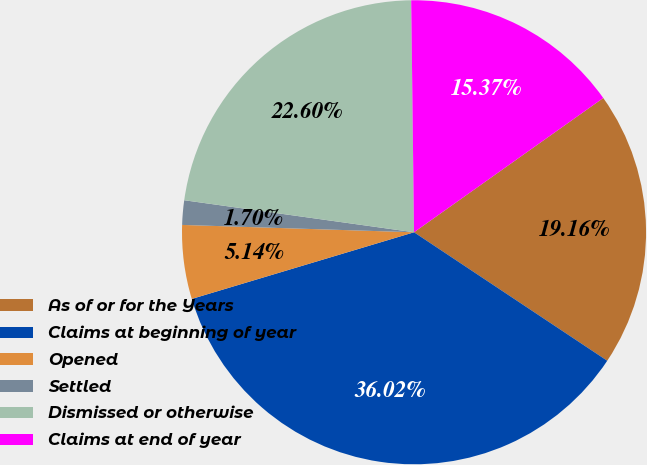Convert chart. <chart><loc_0><loc_0><loc_500><loc_500><pie_chart><fcel>As of or for the Years<fcel>Claims at beginning of year<fcel>Opened<fcel>Settled<fcel>Dismissed or otherwise<fcel>Claims at end of year<nl><fcel>19.16%<fcel>36.02%<fcel>5.14%<fcel>1.7%<fcel>22.6%<fcel>15.37%<nl></chart> 